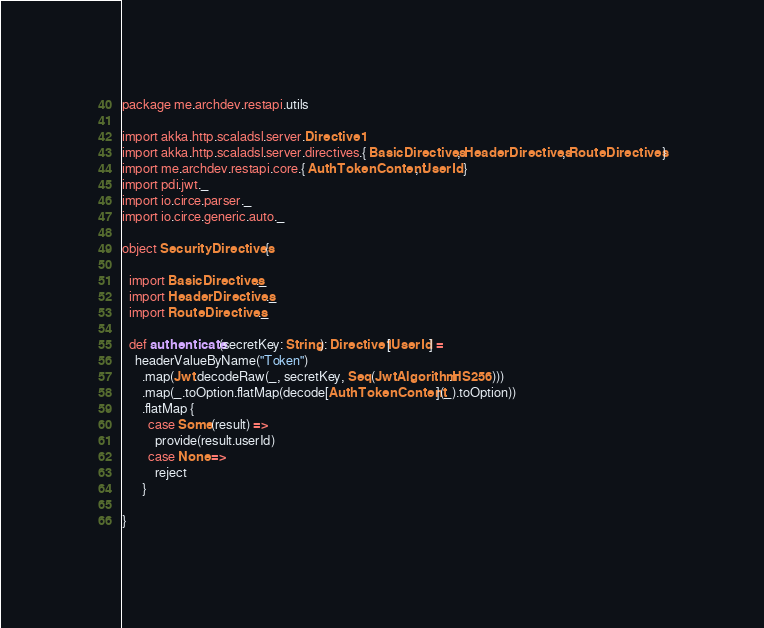Convert code to text. <code><loc_0><loc_0><loc_500><loc_500><_Scala_>package me.archdev.restapi.utils

import akka.http.scaladsl.server.Directive1
import akka.http.scaladsl.server.directives.{ BasicDirectives, HeaderDirectives, RouteDirectives }
import me.archdev.restapi.core.{ AuthTokenContent, UserId }
import pdi.jwt._
import io.circe.parser._
import io.circe.generic.auto._

object SecurityDirectives {

  import BasicDirectives._
  import HeaderDirectives._
  import RouteDirectives._

  def authenticate(secretKey: String): Directive1[UserId] =
    headerValueByName("Token")
      .map(Jwt.decodeRaw(_, secretKey, Seq(JwtAlgorithm.HS256)))
      .map(_.toOption.flatMap(decode[AuthTokenContent](_).toOption))
      .flatMap {
        case Some(result) =>
          provide(result.userId)
        case None =>
          reject
      }

}
</code> 